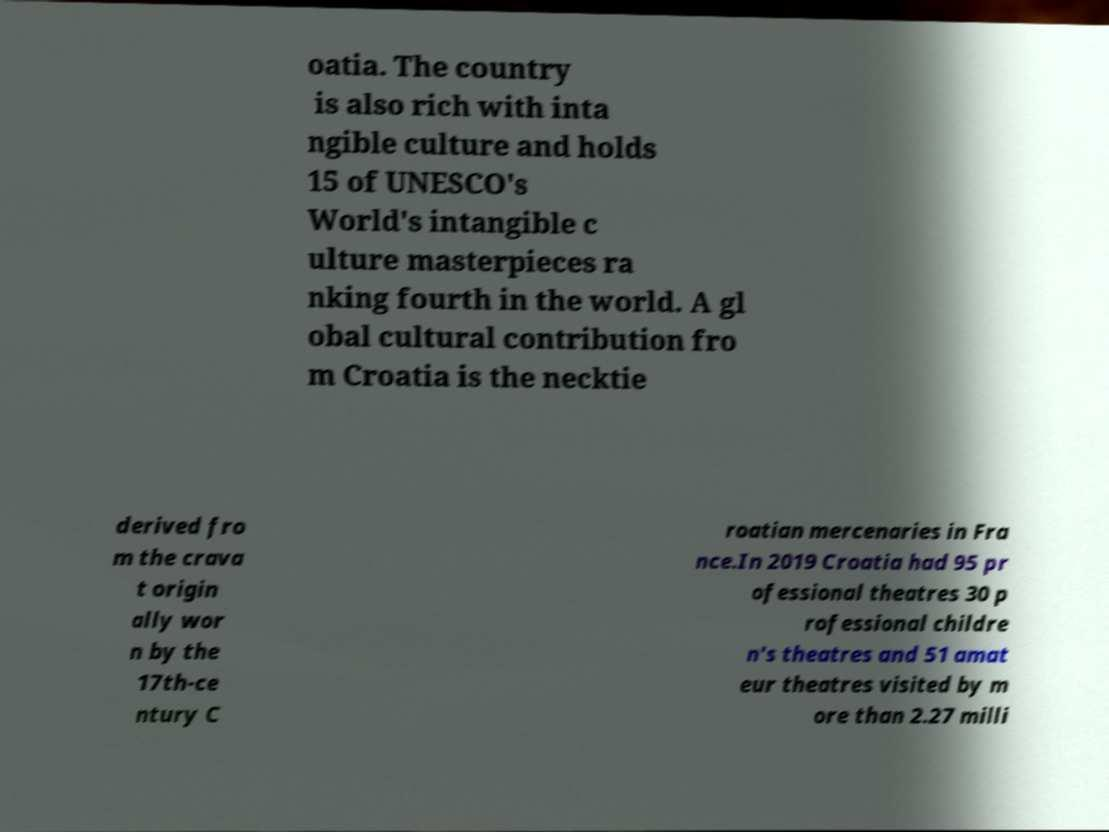Can you read and provide the text displayed in the image?This photo seems to have some interesting text. Can you extract and type it out for me? oatia. The country is also rich with inta ngible culture and holds 15 of UNESCO's World's intangible c ulture masterpieces ra nking fourth in the world. A gl obal cultural contribution fro m Croatia is the necktie derived fro m the crava t origin ally wor n by the 17th-ce ntury C roatian mercenaries in Fra nce.In 2019 Croatia had 95 pr ofessional theatres 30 p rofessional childre n's theatres and 51 amat eur theatres visited by m ore than 2.27 milli 